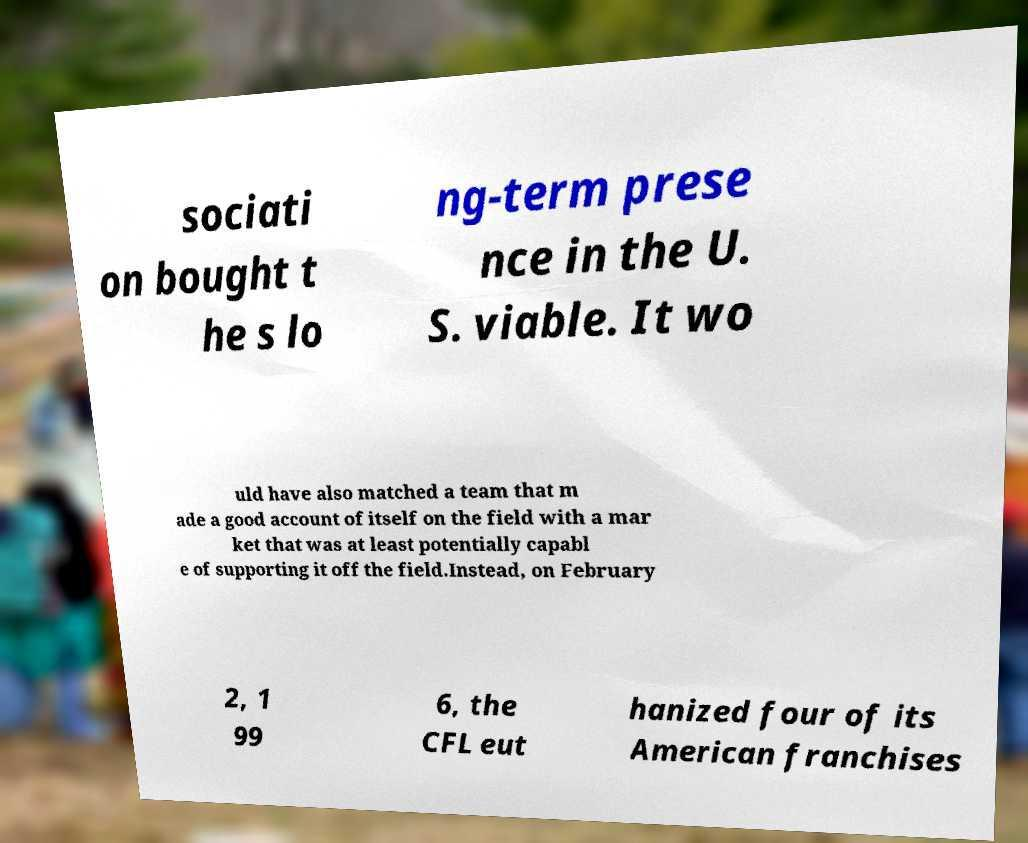Please identify and transcribe the text found in this image. sociati on bought t he s lo ng-term prese nce in the U. S. viable. It wo uld have also matched a team that m ade a good account of itself on the field with a mar ket that was at least potentially capabl e of supporting it off the field.Instead, on February 2, 1 99 6, the CFL eut hanized four of its American franchises 